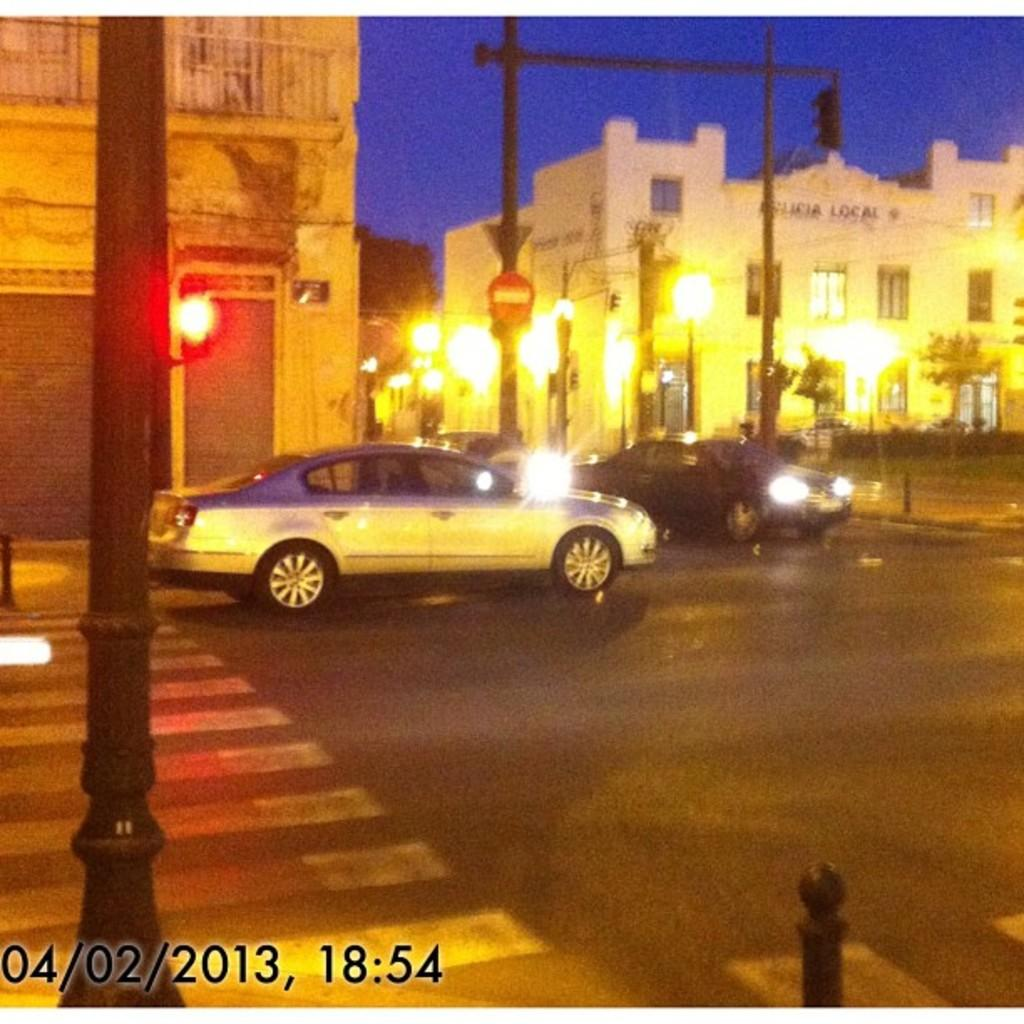Provide a one-sentence caption for the provided image. a car on the street on April 2nd 2013. 